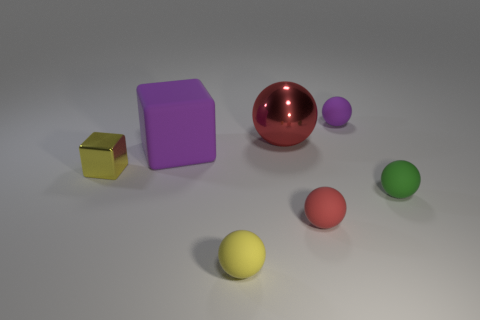Subtract all purple matte balls. How many balls are left? 4 Subtract all purple balls. How many balls are left? 4 Subtract all blue spheres. Subtract all cyan cylinders. How many spheres are left? 5 Add 1 small yellow objects. How many objects exist? 8 Subtract all balls. How many objects are left? 2 Add 7 metallic spheres. How many metallic spheres are left? 8 Add 5 large red spheres. How many large red spheres exist? 6 Subtract 0 gray balls. How many objects are left? 7 Subtract all tiny green matte things. Subtract all large blue shiny cylinders. How many objects are left? 6 